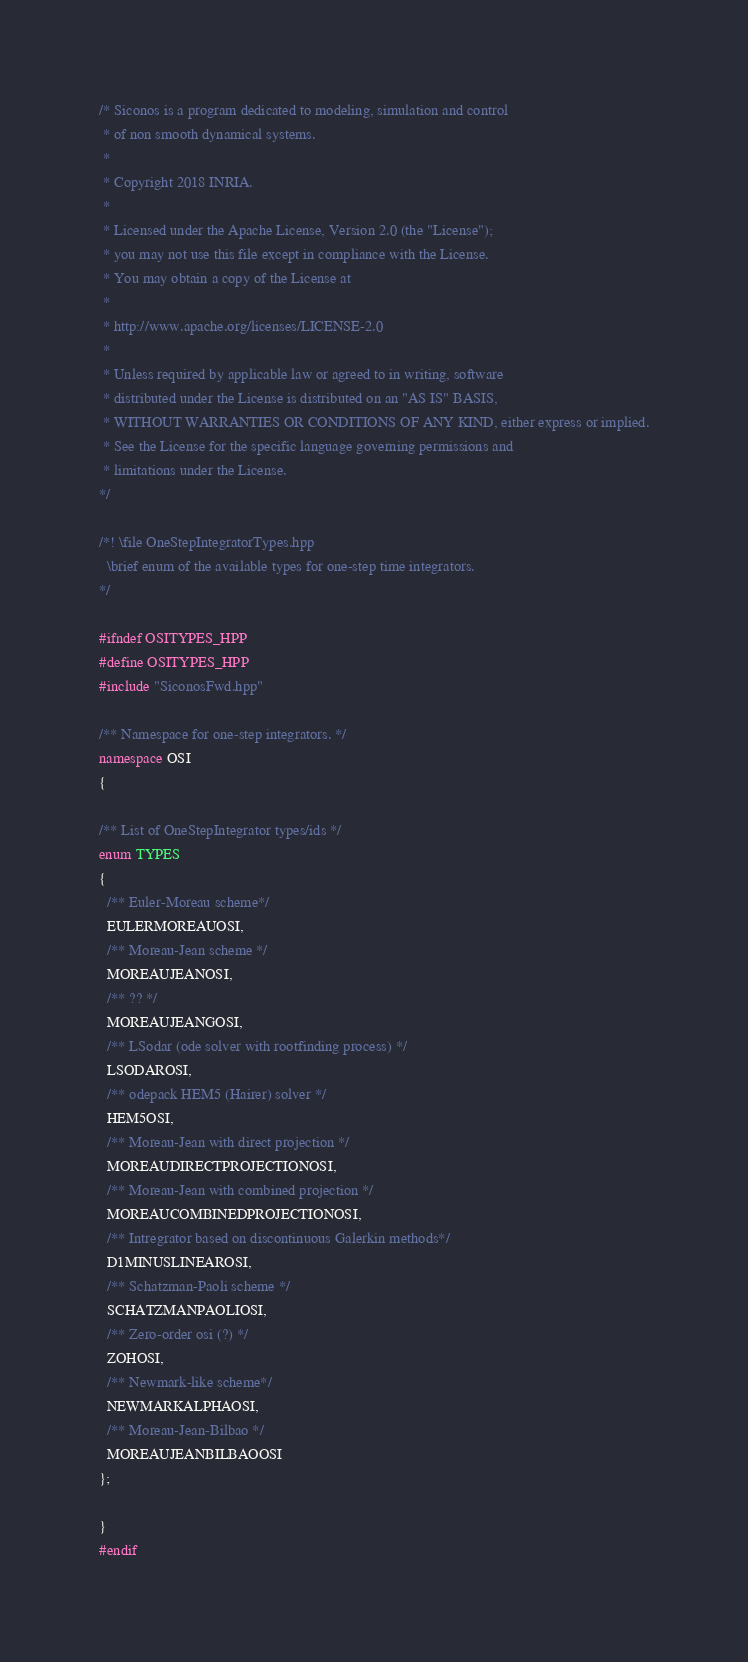Convert code to text. <code><loc_0><loc_0><loc_500><loc_500><_C++_>/* Siconos is a program dedicated to modeling, simulation and control
 * of non smooth dynamical systems.
 *
 * Copyright 2018 INRIA.
 *
 * Licensed under the Apache License, Version 2.0 (the "License");
 * you may not use this file except in compliance with the License.
 * You may obtain a copy of the License at
 *
 * http://www.apache.org/licenses/LICENSE-2.0
 *
 * Unless required by applicable law or agreed to in writing, software
 * distributed under the License is distributed on an "AS IS" BASIS,
 * WITHOUT WARRANTIES OR CONDITIONS OF ANY KIND, either express or implied.
 * See the License for the specific language governing permissions and
 * limitations under the License.
*/

/*! \file OneStepIntegratorTypes.hpp
  \brief enum of the available types for one-step time integrators.
*/

#ifndef OSITYPES_HPP
#define OSITYPES_HPP
#include "SiconosFwd.hpp"

/** Namespace for one-step integrators. */
namespace OSI
{

/** List of OneStepIntegrator types/ids */
enum TYPES
{
  /** Euler-Moreau scheme*/
  EULERMOREAUOSI,
  /** Moreau-Jean scheme */
  MOREAUJEANOSI,
  /** ?? */
  MOREAUJEANGOSI,
  /** LSodar (ode solver with rootfinding process) */
  LSODAROSI,
  /** odepack HEM5 (Hairer) solver */
  HEM5OSI,
  /** Moreau-Jean with direct projection */
  MOREAUDIRECTPROJECTIONOSI,
  /** Moreau-Jean with combined projection */
  MOREAUCOMBINEDPROJECTIONOSI,
  /** Intregrator based on discontinuous Galerkin methods*/
  D1MINUSLINEAROSI,
  /** Schatzman-Paoli scheme */
  SCHATZMANPAOLIOSI,
  /** Zero-order osi (?) */
  ZOHOSI,
  /** Newmark-like scheme*/
  NEWMARKALPHAOSI,
  /** Moreau-Jean-Bilbao */
  MOREAUJEANBILBAOOSI
};

}
#endif
</code> 